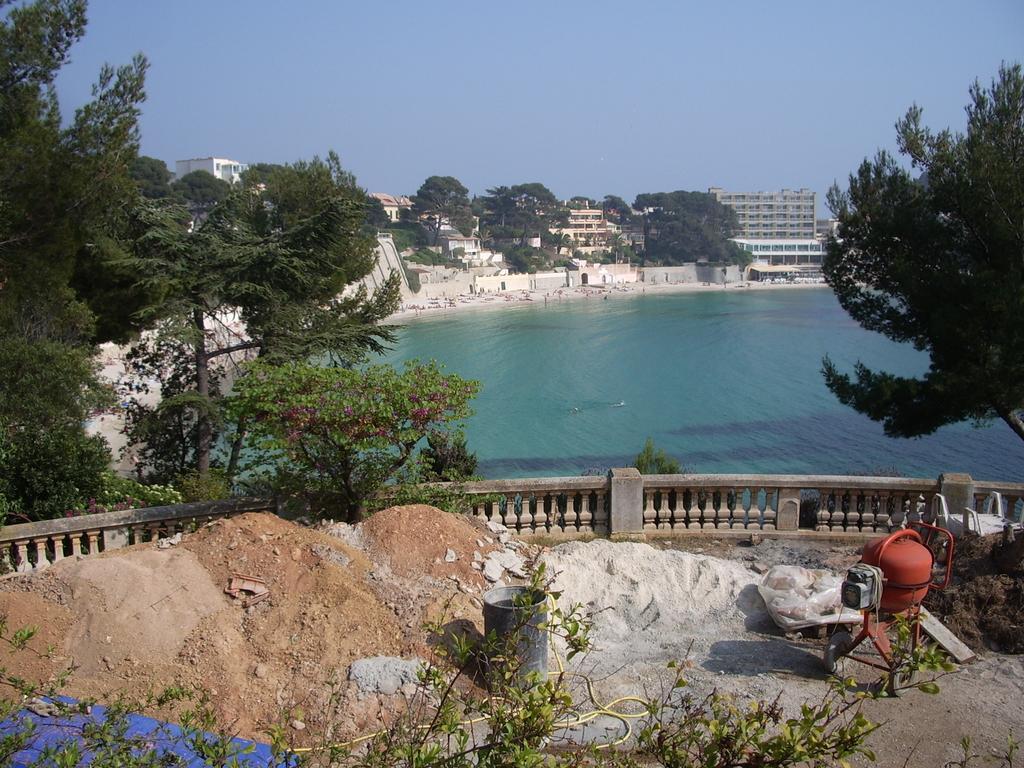In one or two sentences, can you explain what this image depicts? In this image there is a sand at the bottom. In the middle there is water. On the left side there are trees. At the top there is the sky. In the middle we can see there are so many buildings one beside the other. There is a railing around the sand at the bottom. 